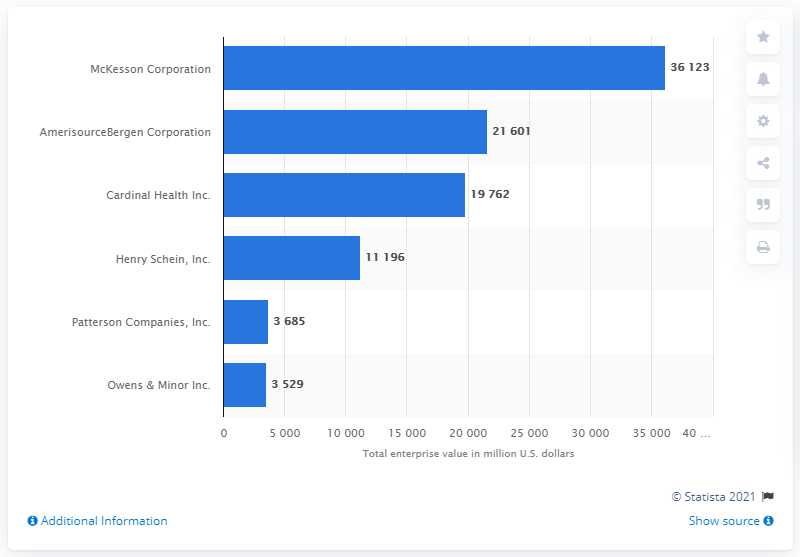Identify some key points in this picture. The total enterprise value of Cardinal Health Inc. as of January 31, 2021 was 19,762. 